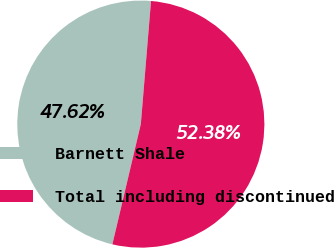Convert chart to OTSL. <chart><loc_0><loc_0><loc_500><loc_500><pie_chart><fcel>Barnett Shale<fcel>Total including discontinued<nl><fcel>47.62%<fcel>52.38%<nl></chart> 